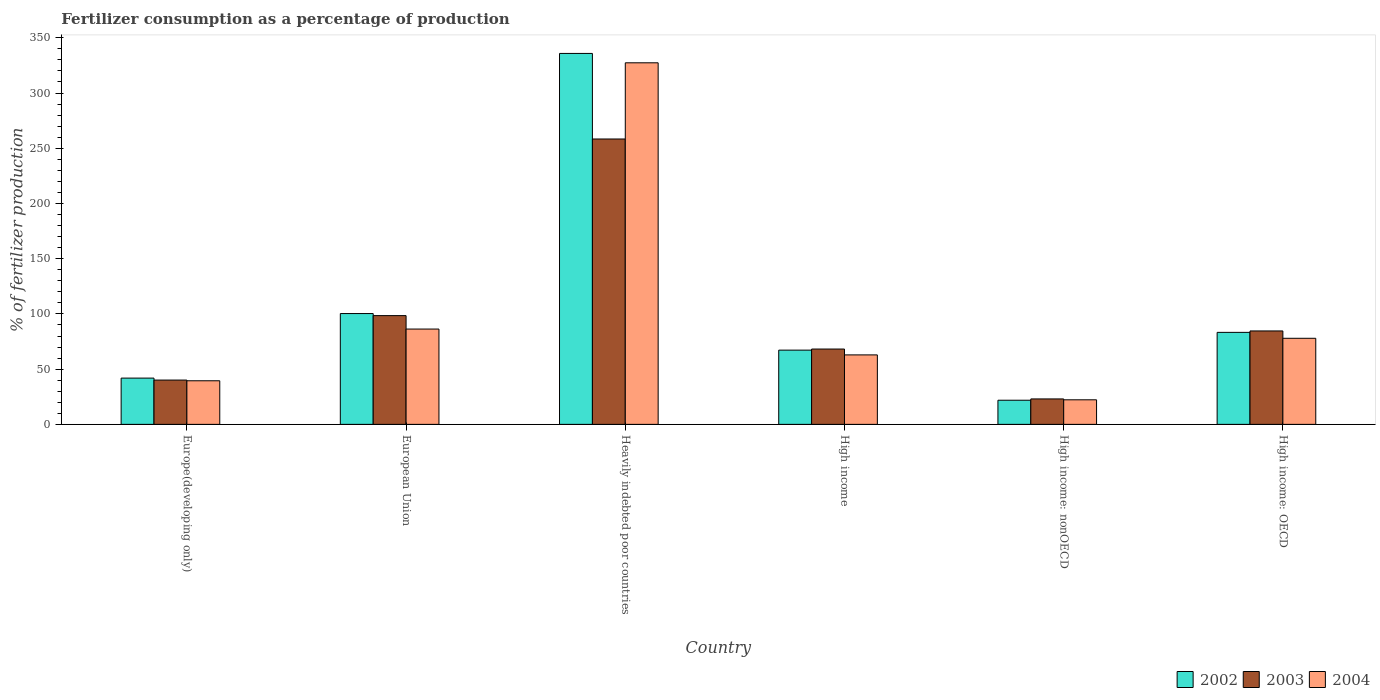How many different coloured bars are there?
Provide a succinct answer. 3. Are the number of bars per tick equal to the number of legend labels?
Keep it short and to the point. Yes. Are the number of bars on each tick of the X-axis equal?
Give a very brief answer. Yes. How many bars are there on the 5th tick from the right?
Keep it short and to the point. 3. What is the label of the 3rd group of bars from the left?
Provide a succinct answer. Heavily indebted poor countries. In how many cases, is the number of bars for a given country not equal to the number of legend labels?
Ensure brevity in your answer.  0. What is the percentage of fertilizers consumed in 2004 in Heavily indebted poor countries?
Keep it short and to the point. 327.38. Across all countries, what is the maximum percentage of fertilizers consumed in 2002?
Your answer should be very brief. 335.87. Across all countries, what is the minimum percentage of fertilizers consumed in 2003?
Offer a terse response. 23.04. In which country was the percentage of fertilizers consumed in 2002 maximum?
Your response must be concise. Heavily indebted poor countries. In which country was the percentage of fertilizers consumed in 2002 minimum?
Your answer should be compact. High income: nonOECD. What is the total percentage of fertilizers consumed in 2002 in the graph?
Your response must be concise. 650.51. What is the difference between the percentage of fertilizers consumed in 2002 in European Union and that in High income: nonOECD?
Your answer should be very brief. 78.48. What is the difference between the percentage of fertilizers consumed in 2004 in Europe(developing only) and the percentage of fertilizers consumed in 2002 in European Union?
Keep it short and to the point. -60.87. What is the average percentage of fertilizers consumed in 2004 per country?
Your answer should be compact. 102.71. What is the difference between the percentage of fertilizers consumed of/in 2003 and percentage of fertilizers consumed of/in 2004 in Europe(developing only)?
Your response must be concise. 0.64. What is the ratio of the percentage of fertilizers consumed in 2002 in Europe(developing only) to that in High income?
Keep it short and to the point. 0.62. What is the difference between the highest and the second highest percentage of fertilizers consumed in 2002?
Offer a very short reply. -17.04. What is the difference between the highest and the lowest percentage of fertilizers consumed in 2004?
Provide a short and direct response. 305.14. In how many countries, is the percentage of fertilizers consumed in 2003 greater than the average percentage of fertilizers consumed in 2003 taken over all countries?
Offer a very short reply. 2. How many bars are there?
Ensure brevity in your answer.  18. Are all the bars in the graph horizontal?
Provide a short and direct response. No. What is the difference between two consecutive major ticks on the Y-axis?
Offer a terse response. 50. How many legend labels are there?
Provide a short and direct response. 3. How are the legend labels stacked?
Your response must be concise. Horizontal. What is the title of the graph?
Provide a short and direct response. Fertilizer consumption as a percentage of production. What is the label or title of the Y-axis?
Ensure brevity in your answer.  % of fertilizer production. What is the % of fertilizer production of 2002 in Europe(developing only)?
Offer a terse response. 41.9. What is the % of fertilizer production of 2003 in Europe(developing only)?
Your response must be concise. 40.11. What is the % of fertilizer production of 2004 in Europe(developing only)?
Offer a terse response. 39.47. What is the % of fertilizer production of 2002 in European Union?
Your answer should be compact. 100.34. What is the % of fertilizer production in 2003 in European Union?
Make the answer very short. 98.48. What is the % of fertilizer production of 2004 in European Union?
Give a very brief answer. 86.31. What is the % of fertilizer production of 2002 in Heavily indebted poor countries?
Keep it short and to the point. 335.87. What is the % of fertilizer production of 2003 in Heavily indebted poor countries?
Provide a succinct answer. 258.39. What is the % of fertilizer production of 2004 in Heavily indebted poor countries?
Your answer should be very brief. 327.38. What is the % of fertilizer production of 2002 in High income?
Give a very brief answer. 67.22. What is the % of fertilizer production of 2003 in High income?
Keep it short and to the point. 68.21. What is the % of fertilizer production in 2004 in High income?
Offer a very short reply. 62.91. What is the % of fertilizer production in 2002 in High income: nonOECD?
Offer a terse response. 21.86. What is the % of fertilizer production of 2003 in High income: nonOECD?
Your answer should be compact. 23.04. What is the % of fertilizer production in 2004 in High income: nonOECD?
Keep it short and to the point. 22.24. What is the % of fertilizer production in 2002 in High income: OECD?
Offer a terse response. 83.31. What is the % of fertilizer production of 2003 in High income: OECD?
Make the answer very short. 84.59. What is the % of fertilizer production in 2004 in High income: OECD?
Offer a very short reply. 77.94. Across all countries, what is the maximum % of fertilizer production in 2002?
Offer a terse response. 335.87. Across all countries, what is the maximum % of fertilizer production of 2003?
Give a very brief answer. 258.39. Across all countries, what is the maximum % of fertilizer production of 2004?
Ensure brevity in your answer.  327.38. Across all countries, what is the minimum % of fertilizer production in 2002?
Provide a succinct answer. 21.86. Across all countries, what is the minimum % of fertilizer production of 2003?
Your answer should be compact. 23.04. Across all countries, what is the minimum % of fertilizer production of 2004?
Make the answer very short. 22.24. What is the total % of fertilizer production in 2002 in the graph?
Offer a very short reply. 650.51. What is the total % of fertilizer production of 2003 in the graph?
Ensure brevity in your answer.  572.83. What is the total % of fertilizer production in 2004 in the graph?
Keep it short and to the point. 616.25. What is the difference between the % of fertilizer production in 2002 in Europe(developing only) and that in European Union?
Keep it short and to the point. -58.44. What is the difference between the % of fertilizer production of 2003 in Europe(developing only) and that in European Union?
Offer a terse response. -58.37. What is the difference between the % of fertilizer production in 2004 in Europe(developing only) and that in European Union?
Make the answer very short. -46.84. What is the difference between the % of fertilizer production of 2002 in Europe(developing only) and that in Heavily indebted poor countries?
Make the answer very short. -293.97. What is the difference between the % of fertilizer production in 2003 in Europe(developing only) and that in Heavily indebted poor countries?
Make the answer very short. -218.28. What is the difference between the % of fertilizer production of 2004 in Europe(developing only) and that in Heavily indebted poor countries?
Offer a terse response. -287.91. What is the difference between the % of fertilizer production in 2002 in Europe(developing only) and that in High income?
Give a very brief answer. -25.32. What is the difference between the % of fertilizer production of 2003 in Europe(developing only) and that in High income?
Provide a short and direct response. -28.1. What is the difference between the % of fertilizer production of 2004 in Europe(developing only) and that in High income?
Ensure brevity in your answer.  -23.43. What is the difference between the % of fertilizer production in 2002 in Europe(developing only) and that in High income: nonOECD?
Your answer should be compact. 20.04. What is the difference between the % of fertilizer production of 2003 in Europe(developing only) and that in High income: nonOECD?
Offer a terse response. 17.07. What is the difference between the % of fertilizer production in 2004 in Europe(developing only) and that in High income: nonOECD?
Your answer should be very brief. 17.23. What is the difference between the % of fertilizer production of 2002 in Europe(developing only) and that in High income: OECD?
Your answer should be compact. -41.41. What is the difference between the % of fertilizer production in 2003 in Europe(developing only) and that in High income: OECD?
Make the answer very short. -44.48. What is the difference between the % of fertilizer production in 2004 in Europe(developing only) and that in High income: OECD?
Provide a short and direct response. -38.47. What is the difference between the % of fertilizer production in 2002 in European Union and that in Heavily indebted poor countries?
Keep it short and to the point. -235.53. What is the difference between the % of fertilizer production of 2003 in European Union and that in Heavily indebted poor countries?
Your answer should be compact. -159.91. What is the difference between the % of fertilizer production of 2004 in European Union and that in Heavily indebted poor countries?
Your answer should be very brief. -241.07. What is the difference between the % of fertilizer production in 2002 in European Union and that in High income?
Provide a short and direct response. 33.12. What is the difference between the % of fertilizer production in 2003 in European Union and that in High income?
Give a very brief answer. 30.27. What is the difference between the % of fertilizer production of 2004 in European Union and that in High income?
Make the answer very short. 23.4. What is the difference between the % of fertilizer production in 2002 in European Union and that in High income: nonOECD?
Offer a terse response. 78.48. What is the difference between the % of fertilizer production in 2003 in European Union and that in High income: nonOECD?
Ensure brevity in your answer.  75.44. What is the difference between the % of fertilizer production of 2004 in European Union and that in High income: nonOECD?
Provide a short and direct response. 64.07. What is the difference between the % of fertilizer production of 2002 in European Union and that in High income: OECD?
Offer a very short reply. 17.04. What is the difference between the % of fertilizer production in 2003 in European Union and that in High income: OECD?
Your response must be concise. 13.89. What is the difference between the % of fertilizer production in 2004 in European Union and that in High income: OECD?
Your answer should be very brief. 8.37. What is the difference between the % of fertilizer production of 2002 in Heavily indebted poor countries and that in High income?
Provide a succinct answer. 268.65. What is the difference between the % of fertilizer production of 2003 in Heavily indebted poor countries and that in High income?
Make the answer very short. 190.18. What is the difference between the % of fertilizer production of 2004 in Heavily indebted poor countries and that in High income?
Offer a very short reply. 264.48. What is the difference between the % of fertilizer production of 2002 in Heavily indebted poor countries and that in High income: nonOECD?
Keep it short and to the point. 314.01. What is the difference between the % of fertilizer production in 2003 in Heavily indebted poor countries and that in High income: nonOECD?
Your response must be concise. 235.35. What is the difference between the % of fertilizer production in 2004 in Heavily indebted poor countries and that in High income: nonOECD?
Offer a terse response. 305.14. What is the difference between the % of fertilizer production of 2002 in Heavily indebted poor countries and that in High income: OECD?
Give a very brief answer. 252.56. What is the difference between the % of fertilizer production in 2003 in Heavily indebted poor countries and that in High income: OECD?
Make the answer very short. 173.8. What is the difference between the % of fertilizer production of 2004 in Heavily indebted poor countries and that in High income: OECD?
Provide a short and direct response. 249.44. What is the difference between the % of fertilizer production in 2002 in High income and that in High income: nonOECD?
Provide a short and direct response. 45.36. What is the difference between the % of fertilizer production in 2003 in High income and that in High income: nonOECD?
Keep it short and to the point. 45.17. What is the difference between the % of fertilizer production of 2004 in High income and that in High income: nonOECD?
Provide a short and direct response. 40.67. What is the difference between the % of fertilizer production of 2002 in High income and that in High income: OECD?
Your response must be concise. -16.09. What is the difference between the % of fertilizer production in 2003 in High income and that in High income: OECD?
Provide a short and direct response. -16.38. What is the difference between the % of fertilizer production in 2004 in High income and that in High income: OECD?
Give a very brief answer. -15.04. What is the difference between the % of fertilizer production of 2002 in High income: nonOECD and that in High income: OECD?
Ensure brevity in your answer.  -61.44. What is the difference between the % of fertilizer production of 2003 in High income: nonOECD and that in High income: OECD?
Provide a succinct answer. -61.55. What is the difference between the % of fertilizer production in 2004 in High income: nonOECD and that in High income: OECD?
Keep it short and to the point. -55.7. What is the difference between the % of fertilizer production of 2002 in Europe(developing only) and the % of fertilizer production of 2003 in European Union?
Make the answer very short. -56.58. What is the difference between the % of fertilizer production in 2002 in Europe(developing only) and the % of fertilizer production in 2004 in European Union?
Offer a very short reply. -44.41. What is the difference between the % of fertilizer production of 2003 in Europe(developing only) and the % of fertilizer production of 2004 in European Union?
Your response must be concise. -46.2. What is the difference between the % of fertilizer production of 2002 in Europe(developing only) and the % of fertilizer production of 2003 in Heavily indebted poor countries?
Ensure brevity in your answer.  -216.49. What is the difference between the % of fertilizer production in 2002 in Europe(developing only) and the % of fertilizer production in 2004 in Heavily indebted poor countries?
Give a very brief answer. -285.48. What is the difference between the % of fertilizer production of 2003 in Europe(developing only) and the % of fertilizer production of 2004 in Heavily indebted poor countries?
Offer a terse response. -287.27. What is the difference between the % of fertilizer production of 2002 in Europe(developing only) and the % of fertilizer production of 2003 in High income?
Keep it short and to the point. -26.31. What is the difference between the % of fertilizer production in 2002 in Europe(developing only) and the % of fertilizer production in 2004 in High income?
Offer a terse response. -21.01. What is the difference between the % of fertilizer production of 2003 in Europe(developing only) and the % of fertilizer production of 2004 in High income?
Make the answer very short. -22.8. What is the difference between the % of fertilizer production of 2002 in Europe(developing only) and the % of fertilizer production of 2003 in High income: nonOECD?
Provide a short and direct response. 18.86. What is the difference between the % of fertilizer production of 2002 in Europe(developing only) and the % of fertilizer production of 2004 in High income: nonOECD?
Give a very brief answer. 19.66. What is the difference between the % of fertilizer production in 2003 in Europe(developing only) and the % of fertilizer production in 2004 in High income: nonOECD?
Your response must be concise. 17.87. What is the difference between the % of fertilizer production in 2002 in Europe(developing only) and the % of fertilizer production in 2003 in High income: OECD?
Ensure brevity in your answer.  -42.69. What is the difference between the % of fertilizer production of 2002 in Europe(developing only) and the % of fertilizer production of 2004 in High income: OECD?
Ensure brevity in your answer.  -36.04. What is the difference between the % of fertilizer production of 2003 in Europe(developing only) and the % of fertilizer production of 2004 in High income: OECD?
Make the answer very short. -37.83. What is the difference between the % of fertilizer production in 2002 in European Union and the % of fertilizer production in 2003 in Heavily indebted poor countries?
Provide a succinct answer. -158.05. What is the difference between the % of fertilizer production of 2002 in European Union and the % of fertilizer production of 2004 in Heavily indebted poor countries?
Your answer should be compact. -227.04. What is the difference between the % of fertilizer production of 2003 in European Union and the % of fertilizer production of 2004 in Heavily indebted poor countries?
Provide a short and direct response. -228.91. What is the difference between the % of fertilizer production of 2002 in European Union and the % of fertilizer production of 2003 in High income?
Provide a short and direct response. 32.13. What is the difference between the % of fertilizer production in 2002 in European Union and the % of fertilizer production in 2004 in High income?
Offer a terse response. 37.44. What is the difference between the % of fertilizer production in 2003 in European Union and the % of fertilizer production in 2004 in High income?
Keep it short and to the point. 35.57. What is the difference between the % of fertilizer production of 2002 in European Union and the % of fertilizer production of 2003 in High income: nonOECD?
Ensure brevity in your answer.  77.3. What is the difference between the % of fertilizer production of 2002 in European Union and the % of fertilizer production of 2004 in High income: nonOECD?
Ensure brevity in your answer.  78.1. What is the difference between the % of fertilizer production in 2003 in European Union and the % of fertilizer production in 2004 in High income: nonOECD?
Provide a succinct answer. 76.24. What is the difference between the % of fertilizer production of 2002 in European Union and the % of fertilizer production of 2003 in High income: OECD?
Offer a very short reply. 15.75. What is the difference between the % of fertilizer production of 2002 in European Union and the % of fertilizer production of 2004 in High income: OECD?
Offer a terse response. 22.4. What is the difference between the % of fertilizer production in 2003 in European Union and the % of fertilizer production in 2004 in High income: OECD?
Your answer should be very brief. 20.54. What is the difference between the % of fertilizer production of 2002 in Heavily indebted poor countries and the % of fertilizer production of 2003 in High income?
Your response must be concise. 267.66. What is the difference between the % of fertilizer production of 2002 in Heavily indebted poor countries and the % of fertilizer production of 2004 in High income?
Ensure brevity in your answer.  272.97. What is the difference between the % of fertilizer production in 2003 in Heavily indebted poor countries and the % of fertilizer production in 2004 in High income?
Keep it short and to the point. 195.48. What is the difference between the % of fertilizer production of 2002 in Heavily indebted poor countries and the % of fertilizer production of 2003 in High income: nonOECD?
Make the answer very short. 312.83. What is the difference between the % of fertilizer production of 2002 in Heavily indebted poor countries and the % of fertilizer production of 2004 in High income: nonOECD?
Ensure brevity in your answer.  313.63. What is the difference between the % of fertilizer production of 2003 in Heavily indebted poor countries and the % of fertilizer production of 2004 in High income: nonOECD?
Your response must be concise. 236.15. What is the difference between the % of fertilizer production in 2002 in Heavily indebted poor countries and the % of fertilizer production in 2003 in High income: OECD?
Ensure brevity in your answer.  251.28. What is the difference between the % of fertilizer production of 2002 in Heavily indebted poor countries and the % of fertilizer production of 2004 in High income: OECD?
Provide a short and direct response. 257.93. What is the difference between the % of fertilizer production of 2003 in Heavily indebted poor countries and the % of fertilizer production of 2004 in High income: OECD?
Provide a succinct answer. 180.45. What is the difference between the % of fertilizer production in 2002 in High income and the % of fertilizer production in 2003 in High income: nonOECD?
Provide a succinct answer. 44.18. What is the difference between the % of fertilizer production in 2002 in High income and the % of fertilizer production in 2004 in High income: nonOECD?
Provide a succinct answer. 44.98. What is the difference between the % of fertilizer production of 2003 in High income and the % of fertilizer production of 2004 in High income: nonOECD?
Your answer should be compact. 45.97. What is the difference between the % of fertilizer production in 2002 in High income and the % of fertilizer production in 2003 in High income: OECD?
Your response must be concise. -17.37. What is the difference between the % of fertilizer production in 2002 in High income and the % of fertilizer production in 2004 in High income: OECD?
Your answer should be very brief. -10.72. What is the difference between the % of fertilizer production of 2003 in High income and the % of fertilizer production of 2004 in High income: OECD?
Offer a terse response. -9.73. What is the difference between the % of fertilizer production in 2002 in High income: nonOECD and the % of fertilizer production in 2003 in High income: OECD?
Offer a very short reply. -62.73. What is the difference between the % of fertilizer production in 2002 in High income: nonOECD and the % of fertilizer production in 2004 in High income: OECD?
Your answer should be compact. -56.08. What is the difference between the % of fertilizer production in 2003 in High income: nonOECD and the % of fertilizer production in 2004 in High income: OECD?
Make the answer very short. -54.9. What is the average % of fertilizer production in 2002 per country?
Make the answer very short. 108.42. What is the average % of fertilizer production in 2003 per country?
Keep it short and to the point. 95.47. What is the average % of fertilizer production of 2004 per country?
Your answer should be very brief. 102.71. What is the difference between the % of fertilizer production of 2002 and % of fertilizer production of 2003 in Europe(developing only)?
Give a very brief answer. 1.79. What is the difference between the % of fertilizer production of 2002 and % of fertilizer production of 2004 in Europe(developing only)?
Offer a terse response. 2.43. What is the difference between the % of fertilizer production of 2003 and % of fertilizer production of 2004 in Europe(developing only)?
Give a very brief answer. 0.64. What is the difference between the % of fertilizer production of 2002 and % of fertilizer production of 2003 in European Union?
Offer a terse response. 1.86. What is the difference between the % of fertilizer production in 2002 and % of fertilizer production in 2004 in European Union?
Your answer should be compact. 14.03. What is the difference between the % of fertilizer production of 2003 and % of fertilizer production of 2004 in European Union?
Provide a succinct answer. 12.17. What is the difference between the % of fertilizer production in 2002 and % of fertilizer production in 2003 in Heavily indebted poor countries?
Ensure brevity in your answer.  77.48. What is the difference between the % of fertilizer production of 2002 and % of fertilizer production of 2004 in Heavily indebted poor countries?
Offer a terse response. 8.49. What is the difference between the % of fertilizer production in 2003 and % of fertilizer production in 2004 in Heavily indebted poor countries?
Provide a short and direct response. -68.99. What is the difference between the % of fertilizer production in 2002 and % of fertilizer production in 2003 in High income?
Offer a terse response. -0.99. What is the difference between the % of fertilizer production in 2002 and % of fertilizer production in 2004 in High income?
Offer a very short reply. 4.31. What is the difference between the % of fertilizer production in 2003 and % of fertilizer production in 2004 in High income?
Keep it short and to the point. 5.31. What is the difference between the % of fertilizer production in 2002 and % of fertilizer production in 2003 in High income: nonOECD?
Your response must be concise. -1.18. What is the difference between the % of fertilizer production of 2002 and % of fertilizer production of 2004 in High income: nonOECD?
Keep it short and to the point. -0.38. What is the difference between the % of fertilizer production in 2003 and % of fertilizer production in 2004 in High income: nonOECD?
Offer a very short reply. 0.8. What is the difference between the % of fertilizer production of 2002 and % of fertilizer production of 2003 in High income: OECD?
Make the answer very short. -1.29. What is the difference between the % of fertilizer production in 2002 and % of fertilizer production in 2004 in High income: OECD?
Offer a terse response. 5.36. What is the difference between the % of fertilizer production in 2003 and % of fertilizer production in 2004 in High income: OECD?
Offer a terse response. 6.65. What is the ratio of the % of fertilizer production in 2002 in Europe(developing only) to that in European Union?
Keep it short and to the point. 0.42. What is the ratio of the % of fertilizer production of 2003 in Europe(developing only) to that in European Union?
Provide a succinct answer. 0.41. What is the ratio of the % of fertilizer production of 2004 in Europe(developing only) to that in European Union?
Give a very brief answer. 0.46. What is the ratio of the % of fertilizer production of 2002 in Europe(developing only) to that in Heavily indebted poor countries?
Offer a very short reply. 0.12. What is the ratio of the % of fertilizer production in 2003 in Europe(developing only) to that in Heavily indebted poor countries?
Your answer should be compact. 0.16. What is the ratio of the % of fertilizer production of 2004 in Europe(developing only) to that in Heavily indebted poor countries?
Your answer should be compact. 0.12. What is the ratio of the % of fertilizer production in 2002 in Europe(developing only) to that in High income?
Give a very brief answer. 0.62. What is the ratio of the % of fertilizer production of 2003 in Europe(developing only) to that in High income?
Provide a succinct answer. 0.59. What is the ratio of the % of fertilizer production in 2004 in Europe(developing only) to that in High income?
Provide a succinct answer. 0.63. What is the ratio of the % of fertilizer production in 2002 in Europe(developing only) to that in High income: nonOECD?
Give a very brief answer. 1.92. What is the ratio of the % of fertilizer production of 2003 in Europe(developing only) to that in High income: nonOECD?
Offer a terse response. 1.74. What is the ratio of the % of fertilizer production in 2004 in Europe(developing only) to that in High income: nonOECD?
Your response must be concise. 1.77. What is the ratio of the % of fertilizer production in 2002 in Europe(developing only) to that in High income: OECD?
Make the answer very short. 0.5. What is the ratio of the % of fertilizer production of 2003 in Europe(developing only) to that in High income: OECD?
Offer a very short reply. 0.47. What is the ratio of the % of fertilizer production of 2004 in Europe(developing only) to that in High income: OECD?
Your response must be concise. 0.51. What is the ratio of the % of fertilizer production of 2002 in European Union to that in Heavily indebted poor countries?
Keep it short and to the point. 0.3. What is the ratio of the % of fertilizer production in 2003 in European Union to that in Heavily indebted poor countries?
Offer a terse response. 0.38. What is the ratio of the % of fertilizer production in 2004 in European Union to that in Heavily indebted poor countries?
Give a very brief answer. 0.26. What is the ratio of the % of fertilizer production in 2002 in European Union to that in High income?
Your answer should be very brief. 1.49. What is the ratio of the % of fertilizer production of 2003 in European Union to that in High income?
Your answer should be compact. 1.44. What is the ratio of the % of fertilizer production of 2004 in European Union to that in High income?
Your answer should be very brief. 1.37. What is the ratio of the % of fertilizer production in 2002 in European Union to that in High income: nonOECD?
Offer a very short reply. 4.59. What is the ratio of the % of fertilizer production of 2003 in European Union to that in High income: nonOECD?
Offer a terse response. 4.27. What is the ratio of the % of fertilizer production of 2004 in European Union to that in High income: nonOECD?
Make the answer very short. 3.88. What is the ratio of the % of fertilizer production of 2002 in European Union to that in High income: OECD?
Give a very brief answer. 1.2. What is the ratio of the % of fertilizer production of 2003 in European Union to that in High income: OECD?
Keep it short and to the point. 1.16. What is the ratio of the % of fertilizer production of 2004 in European Union to that in High income: OECD?
Your answer should be very brief. 1.11. What is the ratio of the % of fertilizer production of 2002 in Heavily indebted poor countries to that in High income?
Provide a succinct answer. 5. What is the ratio of the % of fertilizer production in 2003 in Heavily indebted poor countries to that in High income?
Your answer should be compact. 3.79. What is the ratio of the % of fertilizer production in 2004 in Heavily indebted poor countries to that in High income?
Provide a succinct answer. 5.2. What is the ratio of the % of fertilizer production in 2002 in Heavily indebted poor countries to that in High income: nonOECD?
Keep it short and to the point. 15.36. What is the ratio of the % of fertilizer production of 2003 in Heavily indebted poor countries to that in High income: nonOECD?
Your answer should be compact. 11.21. What is the ratio of the % of fertilizer production of 2004 in Heavily indebted poor countries to that in High income: nonOECD?
Your answer should be compact. 14.72. What is the ratio of the % of fertilizer production in 2002 in Heavily indebted poor countries to that in High income: OECD?
Make the answer very short. 4.03. What is the ratio of the % of fertilizer production of 2003 in Heavily indebted poor countries to that in High income: OECD?
Your answer should be compact. 3.05. What is the ratio of the % of fertilizer production of 2004 in Heavily indebted poor countries to that in High income: OECD?
Provide a short and direct response. 4.2. What is the ratio of the % of fertilizer production in 2002 in High income to that in High income: nonOECD?
Give a very brief answer. 3.07. What is the ratio of the % of fertilizer production in 2003 in High income to that in High income: nonOECD?
Your response must be concise. 2.96. What is the ratio of the % of fertilizer production of 2004 in High income to that in High income: nonOECD?
Your answer should be very brief. 2.83. What is the ratio of the % of fertilizer production of 2002 in High income to that in High income: OECD?
Provide a succinct answer. 0.81. What is the ratio of the % of fertilizer production in 2003 in High income to that in High income: OECD?
Ensure brevity in your answer.  0.81. What is the ratio of the % of fertilizer production in 2004 in High income to that in High income: OECD?
Keep it short and to the point. 0.81. What is the ratio of the % of fertilizer production in 2002 in High income: nonOECD to that in High income: OECD?
Make the answer very short. 0.26. What is the ratio of the % of fertilizer production in 2003 in High income: nonOECD to that in High income: OECD?
Keep it short and to the point. 0.27. What is the ratio of the % of fertilizer production of 2004 in High income: nonOECD to that in High income: OECD?
Your response must be concise. 0.29. What is the difference between the highest and the second highest % of fertilizer production of 2002?
Ensure brevity in your answer.  235.53. What is the difference between the highest and the second highest % of fertilizer production of 2003?
Give a very brief answer. 159.91. What is the difference between the highest and the second highest % of fertilizer production in 2004?
Ensure brevity in your answer.  241.07. What is the difference between the highest and the lowest % of fertilizer production in 2002?
Your answer should be compact. 314.01. What is the difference between the highest and the lowest % of fertilizer production of 2003?
Make the answer very short. 235.35. What is the difference between the highest and the lowest % of fertilizer production of 2004?
Provide a succinct answer. 305.14. 